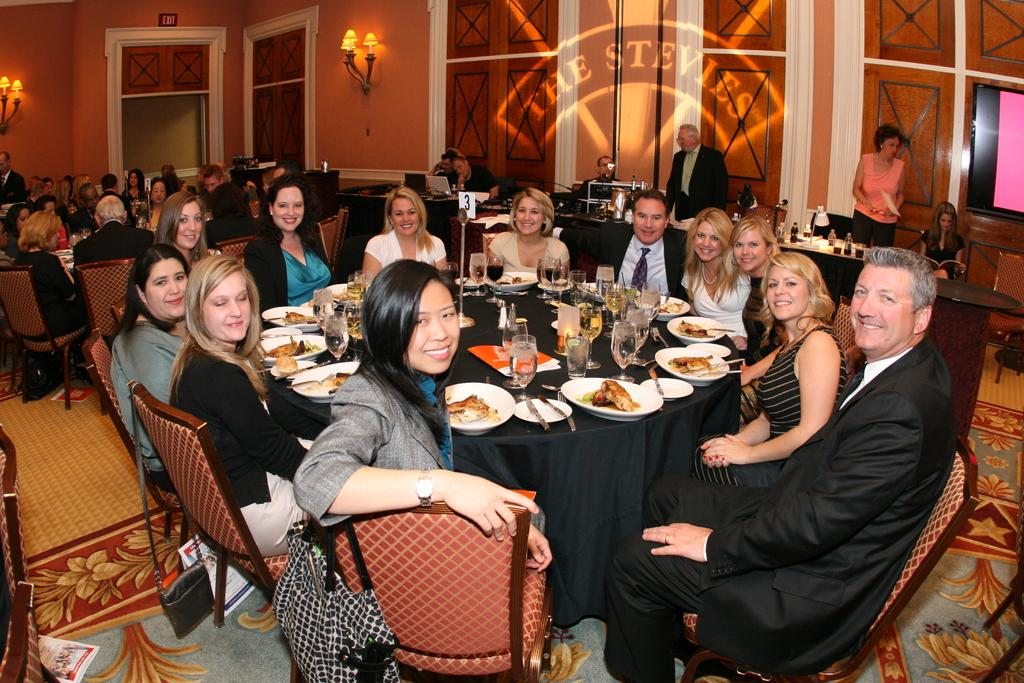How many people are in the image? There is a group of people in the image. What are the people doing in the image? The people are sitting on chairs. Where are the chairs located in relation to the table? The chairs are in front of a table. What can be found on the table in the image? There are plates, glasses, and other objects on the table. What type of alarm is ringing in the image? There is no alarm present in the image. Can you see a snail crawling on the table in the image? There is no snail present in the image. 